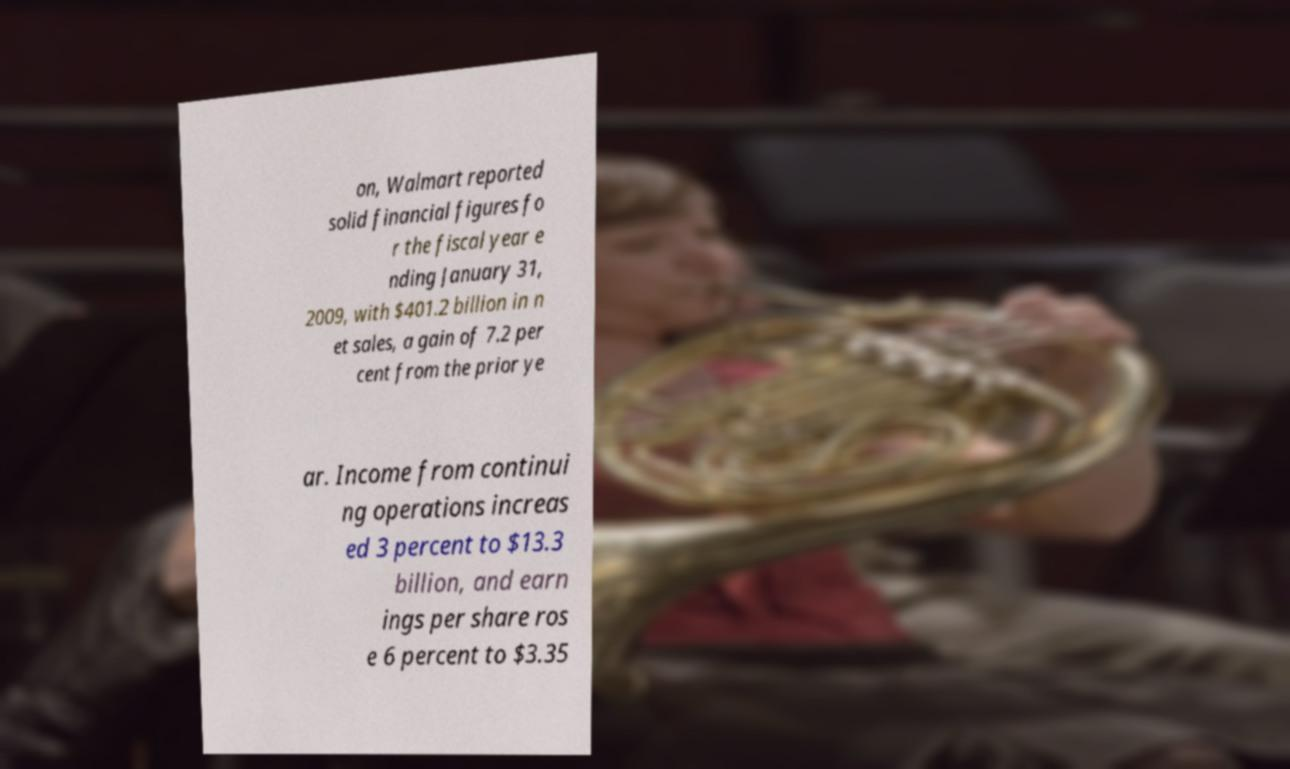Can you accurately transcribe the text from the provided image for me? on, Walmart reported solid financial figures fo r the fiscal year e nding January 31, 2009, with $401.2 billion in n et sales, a gain of 7.2 per cent from the prior ye ar. Income from continui ng operations increas ed 3 percent to $13.3 billion, and earn ings per share ros e 6 percent to $3.35 